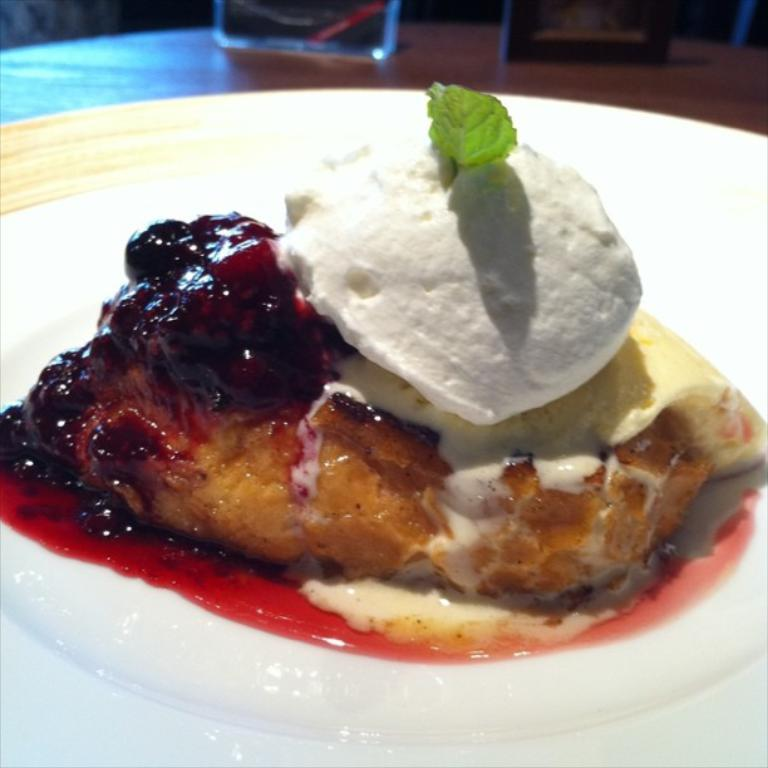What is on the plate that is visible in the image? There is food on a plate in the image. What else can be seen on the table in the image? There is a glass and a board on the table in the image. How many plates are visible in the image? There is one plate visible in the image. What type of circle is present in the image? There is no circle present in the image. What season is depicted in the image? The image does not depict a specific season, so it cannot be determined from the image. 